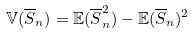Convert formula to latex. <formula><loc_0><loc_0><loc_500><loc_500>\mathbb { V } ( \overline { S } _ { n } ) = \mathbb { E } ( \overline { S } _ { n } ^ { 2 } ) - \mathbb { E } ( \overline { S } _ { n } ) ^ { 2 }</formula> 